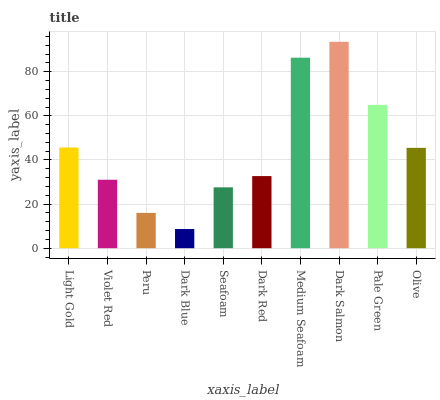Is Dark Blue the minimum?
Answer yes or no. Yes. Is Dark Salmon the maximum?
Answer yes or no. Yes. Is Violet Red the minimum?
Answer yes or no. No. Is Violet Red the maximum?
Answer yes or no. No. Is Light Gold greater than Violet Red?
Answer yes or no. Yes. Is Violet Red less than Light Gold?
Answer yes or no. Yes. Is Violet Red greater than Light Gold?
Answer yes or no. No. Is Light Gold less than Violet Red?
Answer yes or no. No. Is Olive the high median?
Answer yes or no. Yes. Is Dark Red the low median?
Answer yes or no. Yes. Is Medium Seafoam the high median?
Answer yes or no. No. Is Medium Seafoam the low median?
Answer yes or no. No. 